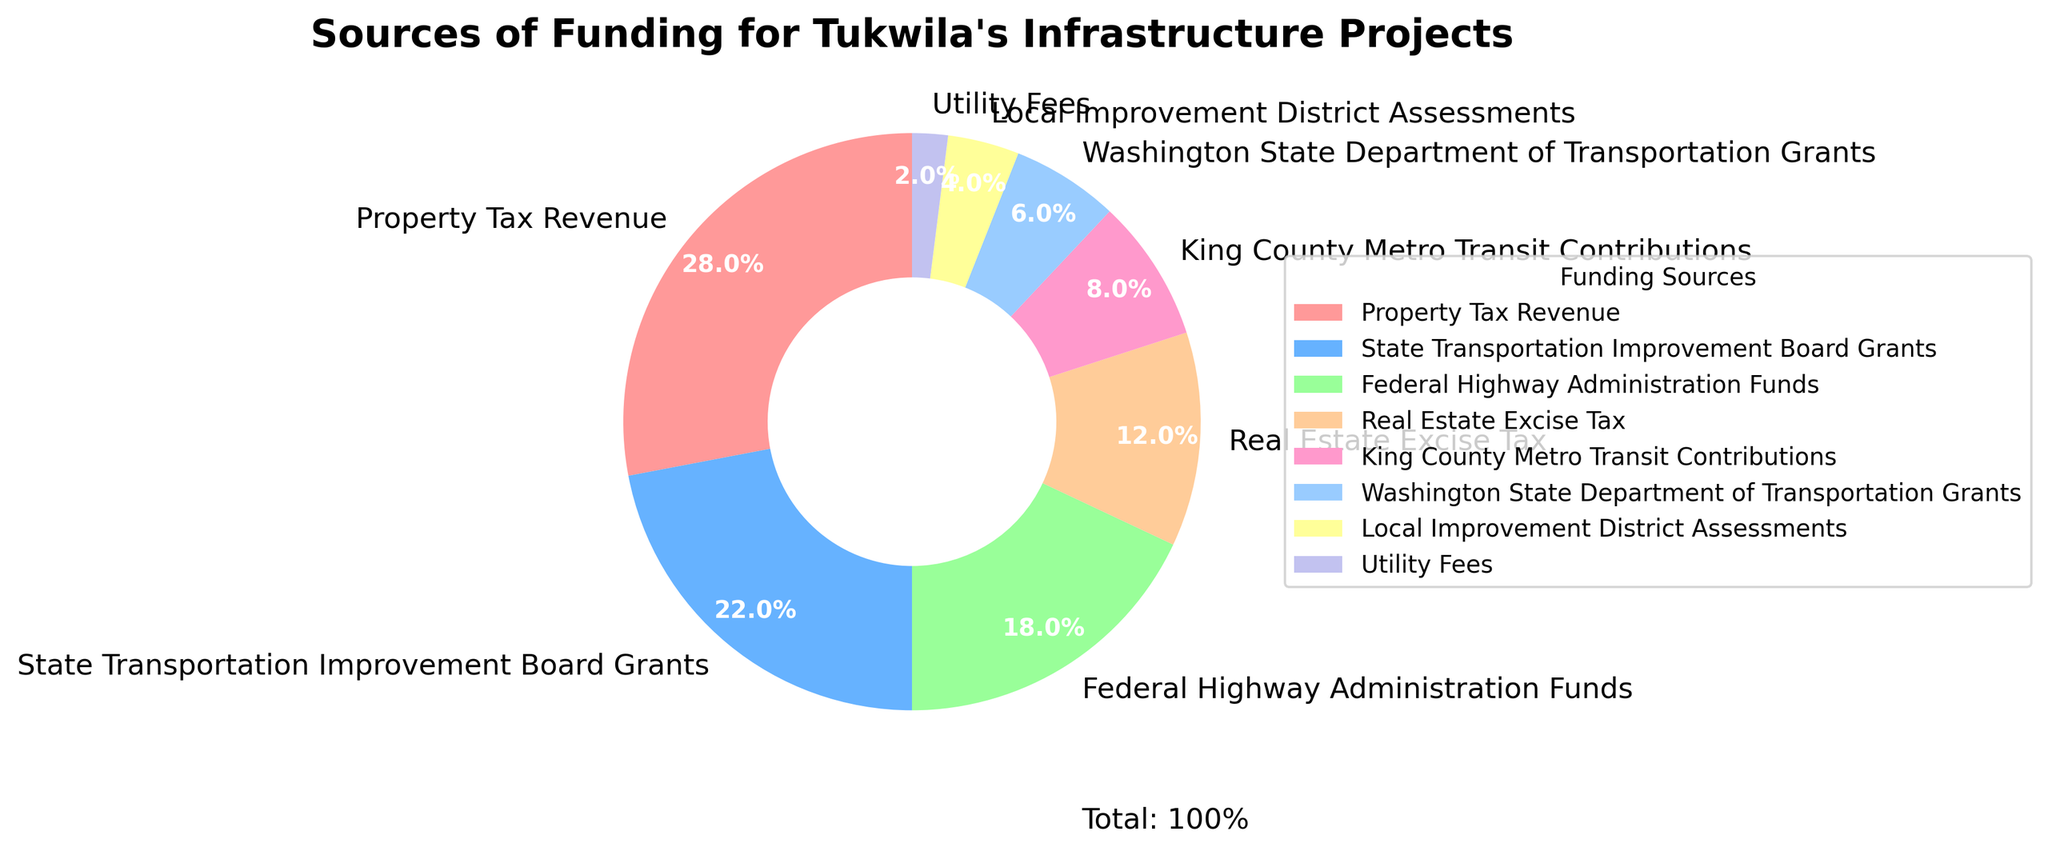What is the percentage of federal funding contribution to Tukwila's infrastructure projects? To determine the percentage of federal funding contribution, look at the label on the corresponding slice in the pie chart. Federal Highway Administration Funds contribute 18% as shown in the chart.
Answer: 18% Which funding source contributes the most to Tukwila's infrastructure projects? The funding source with the largest percentage in the pie chart is the one that contributes the most. From the chart, Property Tax Revenue has the highest contribution at 28%.
Answer: Property Tax Revenue What is the combined percentage of contributions from state-level grants to Tukwila's infrastructure projects? Add the percentages from State Transportation Improvement Board Grants (22%) and Washington State Department of Transportation Grants (6%). The combined contribution is 22% + 6% = 28%.
Answer: 28% How does the contribution from Real Estate Excise Tax compare to King County Metro Transit Contributions? Compare the percentages shown for Real Estate Excise Tax (12%) and King County Metro Transit Contributions (8%). Real Estate Excise Tax has a higher percentage.
Answer: Real Estate Excise Tax has a higher percentage What's the difference in percentage between the highest and lowest contribution sources? The highest contribution source is Property Tax Revenue at 28% and the lowest is Utility Fees at 2%. Subtract the smallest from the largest: 28% - 2% = 26%.
Answer: 26% What is the combined contribution of Property Tax Revenue and Local Improvement District Assessments? Add the percentages from Property Tax Revenue (28%) and Local Improvement District Assessments (4%). The combined contribution is 28% + 4% = 32%.
Answer: 32% Which funding sources contribute equal or less than 10% each? Check the percentages in the chart. Funding sources that contribute 10% or less each are King County Metro Transit Contributions (8%), Washington State Department of Transportation Grants (6%), Local Improvement District Assessments (4%), and Utility Fees (2%).
Answer: King County Metro Transit Contributions, Washington State Department of Transportation Grants, Local Improvement District Assessments, Utility Fees Which color represents the slice with the second largest funding contribution? Identify the slice with the second largest contribution. State Transportation Improvement Board Grants (22%) is second to Property Tax Revenue (28%). Look at the chart to see that State Transportation Improvement Board Grants are represented by the light blue color.
Answer: Light blue 